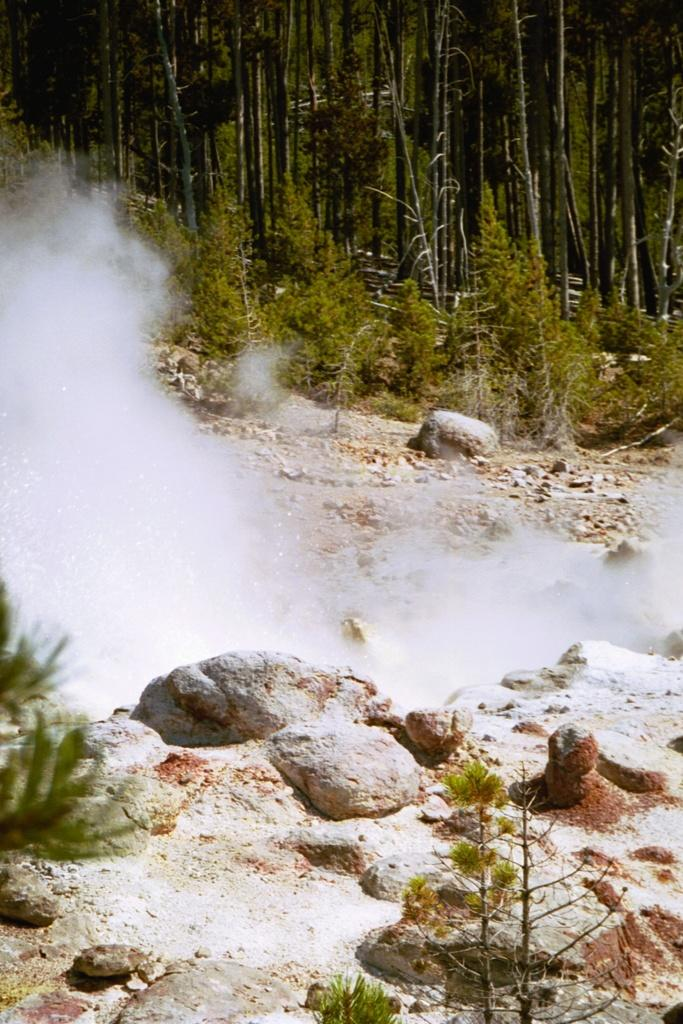What type of surface can be seen in the image? There is a surface with stones and plants in the image. What is visible in the air in the image? There is smoke visible in the image. What kind of path is present in the image? There is a path with stones, plants, and trees in the image. What type of shoe can be seen in the image? There is no shoe present in the image. What kind of agreement is being made in the image? There is no agreement being made in the image; it features a surface, smoke, and a path with stones, plants, and trees. 